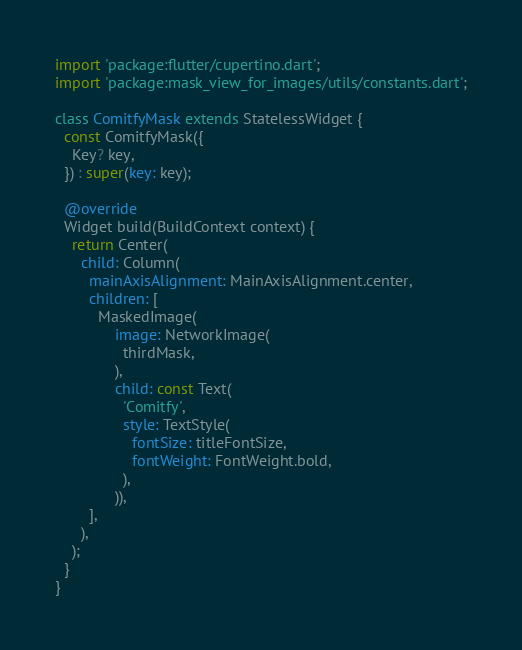<code> <loc_0><loc_0><loc_500><loc_500><_Dart_>import 'package:flutter/cupertino.dart';
import 'package:mask_view_for_images/utils/constants.dart';

class ComitfyMask extends StatelessWidget {
  const ComitfyMask({
    Key? key,
  }) : super(key: key);

  @override
  Widget build(BuildContext context) {
    return Center(
      child: Column(
        mainAxisAlignment: MainAxisAlignment.center,
        children: [
          MaskedImage(
              image: NetworkImage(
                thirdMask,
              ),
              child: const Text(
                'Comitfy',
                style: TextStyle(
                  fontSize: titleFontSize,
                  fontWeight: FontWeight.bold,
                ),
              )),
        ],
      ),
    );
  }
}</code> 